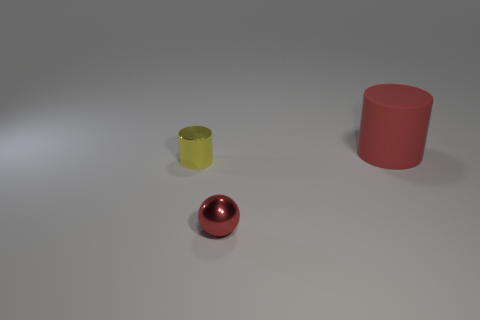The other thing that is the same color as the large rubber object is what size?
Offer a terse response. Small. Is the color of the cylinder that is on the right side of the yellow object the same as the tiny metal ball?
Your answer should be very brief. Yes. Are there any metallic balls of the same color as the large rubber cylinder?
Your response must be concise. Yes. There is a cylinder behind the tiny yellow shiny cylinder; is it the same color as the shiny object right of the small yellow metallic thing?
Provide a succinct answer. Yes. Are any tiny metallic cylinders visible?
Ensure brevity in your answer.  Yes. The thing that is made of the same material as the tiny cylinder is what shape?
Keep it short and to the point. Sphere. Is the shape of the big red object the same as the small metal thing that is behind the red metal thing?
Offer a very short reply. Yes. There is a small object that is in front of the tiny metal thing that is behind the red shiny thing; what is its material?
Your answer should be very brief. Metal. How many other things are there of the same shape as the tiny red object?
Offer a terse response. 0. Is the shape of the red thing that is in front of the red rubber thing the same as the red object that is behind the tiny yellow cylinder?
Make the answer very short. No. 